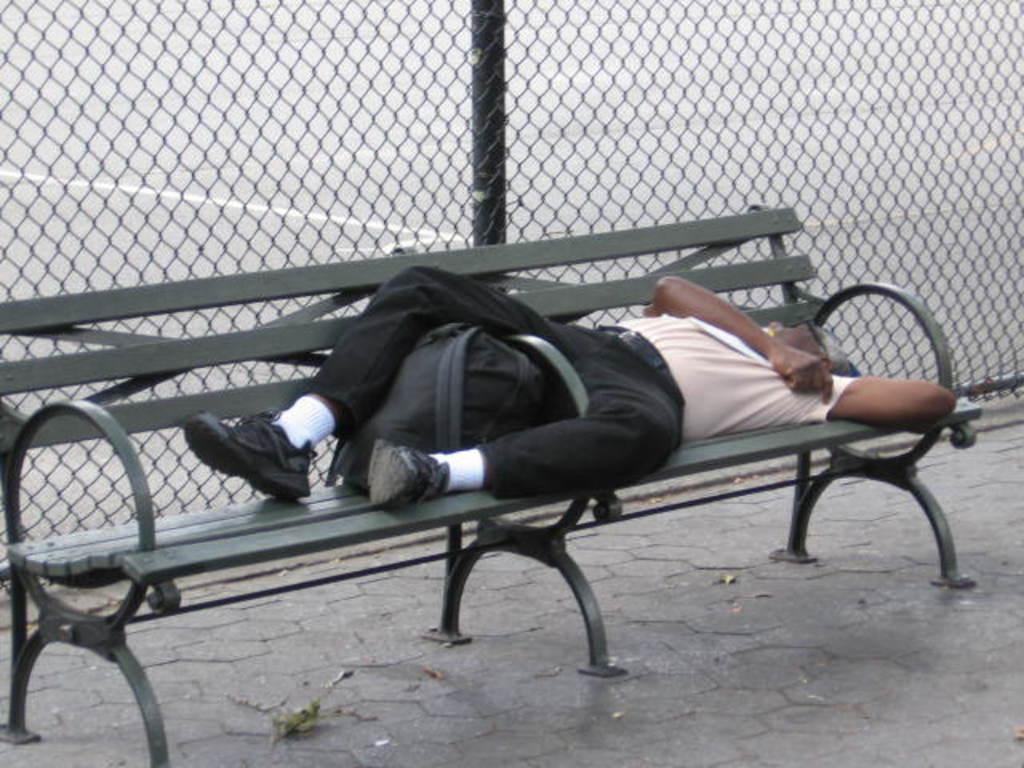How would you summarize this image in a sentence or two? This picture is taken outside the city. Here, we see a man wearing light pink t-shirt and black pant is sleeping on the bench. On bench, we can see a black bag. Behind the bench, we see fence and a pole. I think this bench is placed on footpath. 